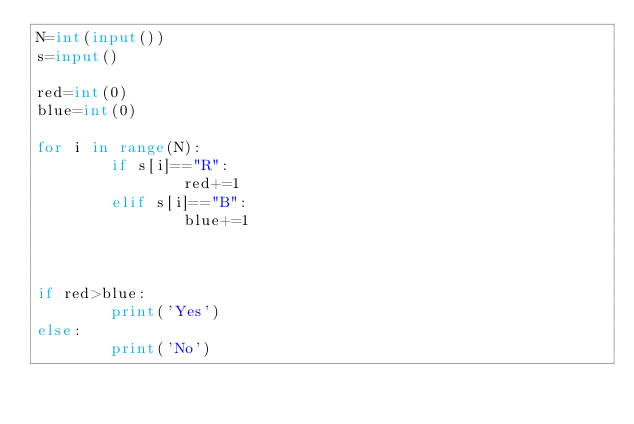Convert code to text. <code><loc_0><loc_0><loc_500><loc_500><_Python_>N=int(input())                                   
s=input()

red=int(0)
blue=int(0)

for i in range(N):
        if s[i]=="R":
                red+=1
        elif s[i]=="B":
                blue+=1



if red>blue:
        print('Yes')
else:
        print('No')</code> 